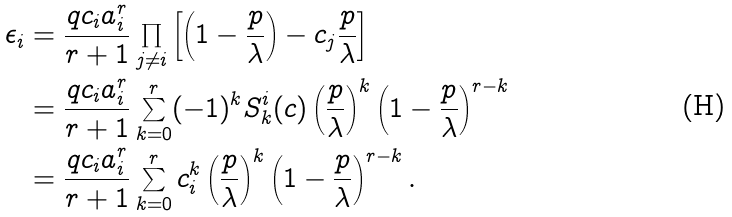<formula> <loc_0><loc_0><loc_500><loc_500>\epsilon _ { i } & = \frac { q c _ { i } a _ { i } ^ { r } } { r + 1 } \prod _ { j \neq i } \left [ \left ( 1 - \frac { p } { \lambda } \right ) - c _ { j } \frac { p } { \lambda } \right ] \\ & = \frac { q c _ { i } a _ { i } ^ { r } } { r + 1 } \sum _ { k = 0 } ^ { r } ( - 1 ) ^ { k } S ^ { i } _ { k } ( c ) \left ( \frac { p } { \lambda } \right ) ^ { k } \left ( 1 - \frac { p } { \lambda } \right ) ^ { r - k } \\ & = \frac { q c _ { i } a _ { i } ^ { r } } { r + 1 } \sum _ { k = 0 } ^ { r } c _ { i } ^ { k } \left ( \frac { p } { \lambda } \right ) ^ { k } \left ( 1 - \frac { p } { \lambda } \right ) ^ { r - k } .</formula> 